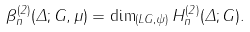Convert formula to latex. <formula><loc_0><loc_0><loc_500><loc_500>\beta _ { n } ^ { ( 2 ) } ( \Delta ; G , \mu ) = \dim _ { ( L G , \psi ) } H _ { n } ^ { ( 2 ) } ( \Delta ; G ) .</formula> 